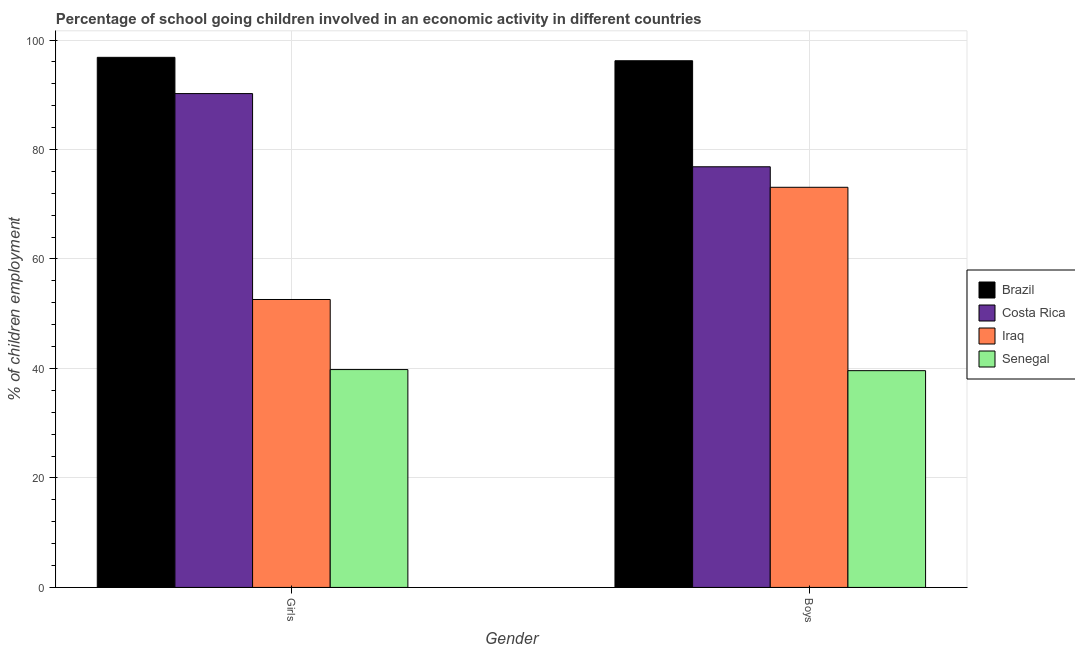Are the number of bars per tick equal to the number of legend labels?
Give a very brief answer. Yes. Are the number of bars on each tick of the X-axis equal?
Provide a short and direct response. Yes. What is the label of the 1st group of bars from the left?
Your answer should be compact. Girls. What is the percentage of school going boys in Iraq?
Give a very brief answer. 73.1. Across all countries, what is the maximum percentage of school going girls?
Offer a very short reply. 96.84. Across all countries, what is the minimum percentage of school going boys?
Give a very brief answer. 39.6. In which country was the percentage of school going girls minimum?
Give a very brief answer. Senegal. What is the total percentage of school going girls in the graph?
Offer a very short reply. 279.46. What is the difference between the percentage of school going boys in Senegal and that in Brazil?
Offer a very short reply. -56.62. What is the difference between the percentage of school going girls in Senegal and the percentage of school going boys in Brazil?
Your answer should be compact. -56.42. What is the average percentage of school going girls per country?
Make the answer very short. 69.86. What is the difference between the percentage of school going girls and percentage of school going boys in Costa Rica?
Provide a succinct answer. 13.37. In how many countries, is the percentage of school going boys greater than 20 %?
Keep it short and to the point. 4. What is the ratio of the percentage of school going girls in Costa Rica to that in Senegal?
Provide a succinct answer. 2.27. In how many countries, is the percentage of school going girls greater than the average percentage of school going girls taken over all countries?
Offer a very short reply. 2. What does the 1st bar from the left in Girls represents?
Make the answer very short. Brazil. What does the 1st bar from the right in Girls represents?
Your response must be concise. Senegal. How many bars are there?
Provide a succinct answer. 8. How many countries are there in the graph?
Offer a very short reply. 4. Does the graph contain any zero values?
Make the answer very short. No. How are the legend labels stacked?
Your answer should be compact. Vertical. What is the title of the graph?
Offer a very short reply. Percentage of school going children involved in an economic activity in different countries. Does "Spain" appear as one of the legend labels in the graph?
Offer a terse response. No. What is the label or title of the X-axis?
Ensure brevity in your answer.  Gender. What is the label or title of the Y-axis?
Give a very brief answer. % of children employment. What is the % of children employment in Brazil in Girls?
Your answer should be very brief. 96.84. What is the % of children employment in Costa Rica in Girls?
Your response must be concise. 90.22. What is the % of children employment in Iraq in Girls?
Offer a terse response. 52.6. What is the % of children employment of Senegal in Girls?
Give a very brief answer. 39.8. What is the % of children employment in Brazil in Boys?
Offer a very short reply. 96.22. What is the % of children employment in Costa Rica in Boys?
Your response must be concise. 76.85. What is the % of children employment of Iraq in Boys?
Offer a terse response. 73.1. What is the % of children employment in Senegal in Boys?
Ensure brevity in your answer.  39.6. Across all Gender, what is the maximum % of children employment of Brazil?
Make the answer very short. 96.84. Across all Gender, what is the maximum % of children employment of Costa Rica?
Offer a very short reply. 90.22. Across all Gender, what is the maximum % of children employment in Iraq?
Offer a terse response. 73.1. Across all Gender, what is the maximum % of children employment in Senegal?
Your answer should be compact. 39.8. Across all Gender, what is the minimum % of children employment of Brazil?
Your answer should be very brief. 96.22. Across all Gender, what is the minimum % of children employment of Costa Rica?
Your answer should be compact. 76.85. Across all Gender, what is the minimum % of children employment in Iraq?
Provide a short and direct response. 52.6. Across all Gender, what is the minimum % of children employment in Senegal?
Make the answer very short. 39.6. What is the total % of children employment of Brazil in the graph?
Your answer should be compact. 193.06. What is the total % of children employment in Costa Rica in the graph?
Keep it short and to the point. 167.06. What is the total % of children employment in Iraq in the graph?
Keep it short and to the point. 125.7. What is the total % of children employment of Senegal in the graph?
Your answer should be compact. 79.4. What is the difference between the % of children employment in Brazil in Girls and that in Boys?
Ensure brevity in your answer.  0.62. What is the difference between the % of children employment of Costa Rica in Girls and that in Boys?
Your response must be concise. 13.37. What is the difference between the % of children employment of Iraq in Girls and that in Boys?
Keep it short and to the point. -20.5. What is the difference between the % of children employment of Brazil in Girls and the % of children employment of Costa Rica in Boys?
Offer a terse response. 19.99. What is the difference between the % of children employment of Brazil in Girls and the % of children employment of Iraq in Boys?
Your response must be concise. 23.74. What is the difference between the % of children employment in Brazil in Girls and the % of children employment in Senegal in Boys?
Provide a succinct answer. 57.24. What is the difference between the % of children employment of Costa Rica in Girls and the % of children employment of Iraq in Boys?
Your answer should be compact. 17.12. What is the difference between the % of children employment in Costa Rica in Girls and the % of children employment in Senegal in Boys?
Give a very brief answer. 50.62. What is the difference between the % of children employment of Iraq in Girls and the % of children employment of Senegal in Boys?
Give a very brief answer. 13. What is the average % of children employment of Brazil per Gender?
Ensure brevity in your answer.  96.53. What is the average % of children employment in Costa Rica per Gender?
Offer a very short reply. 83.53. What is the average % of children employment of Iraq per Gender?
Your answer should be compact. 62.85. What is the average % of children employment of Senegal per Gender?
Offer a very short reply. 39.7. What is the difference between the % of children employment in Brazil and % of children employment in Costa Rica in Girls?
Keep it short and to the point. 6.62. What is the difference between the % of children employment in Brazil and % of children employment in Iraq in Girls?
Offer a very short reply. 44.24. What is the difference between the % of children employment in Brazil and % of children employment in Senegal in Girls?
Ensure brevity in your answer.  57.04. What is the difference between the % of children employment in Costa Rica and % of children employment in Iraq in Girls?
Your answer should be very brief. 37.62. What is the difference between the % of children employment in Costa Rica and % of children employment in Senegal in Girls?
Offer a very short reply. 50.42. What is the difference between the % of children employment in Brazil and % of children employment in Costa Rica in Boys?
Make the answer very short. 19.37. What is the difference between the % of children employment in Brazil and % of children employment in Iraq in Boys?
Offer a terse response. 23.12. What is the difference between the % of children employment in Brazil and % of children employment in Senegal in Boys?
Ensure brevity in your answer.  56.62. What is the difference between the % of children employment in Costa Rica and % of children employment in Iraq in Boys?
Offer a very short reply. 3.75. What is the difference between the % of children employment in Costa Rica and % of children employment in Senegal in Boys?
Keep it short and to the point. 37.25. What is the difference between the % of children employment in Iraq and % of children employment in Senegal in Boys?
Give a very brief answer. 33.5. What is the ratio of the % of children employment in Brazil in Girls to that in Boys?
Your answer should be very brief. 1.01. What is the ratio of the % of children employment in Costa Rica in Girls to that in Boys?
Offer a very short reply. 1.17. What is the ratio of the % of children employment of Iraq in Girls to that in Boys?
Provide a succinct answer. 0.72. What is the difference between the highest and the second highest % of children employment of Brazil?
Offer a terse response. 0.62. What is the difference between the highest and the second highest % of children employment of Costa Rica?
Your answer should be compact. 13.37. What is the difference between the highest and the second highest % of children employment of Senegal?
Your answer should be compact. 0.2. What is the difference between the highest and the lowest % of children employment of Brazil?
Keep it short and to the point. 0.62. What is the difference between the highest and the lowest % of children employment in Costa Rica?
Your response must be concise. 13.37. What is the difference between the highest and the lowest % of children employment of Iraq?
Ensure brevity in your answer.  20.5. 